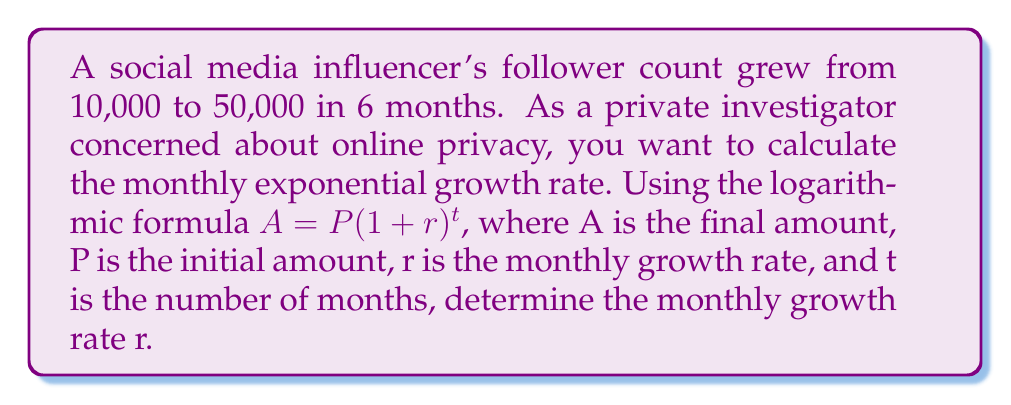Help me with this question. 1. Identify the given values:
   $A = 50,000$ (final follower count)
   $P = 10,000$ (initial follower count)
   $t = 6$ (months)

2. Substitute these values into the formula:
   $50,000 = 10,000(1+r)^6$

3. Divide both sides by 10,000:
   $5 = (1+r)^6$

4. Take the natural logarithm of both sides:
   $\ln(5) = \ln((1+r)^6)$

5. Use the logarithm property $\ln(x^n) = n\ln(x)$:
   $\ln(5) = 6\ln(1+r)$

6. Divide both sides by 6:
   $\frac{\ln(5)}{6} = \ln(1+r)$

7. Take $e$ to the power of both sides:
   $e^{\frac{\ln(5)}{6}} = e^{\ln(1+r)} = 1+r$

8. Subtract 1 from both sides:
   $e^{\frac{\ln(5)}{6}} - 1 = r$

9. Calculate the result:
   $r \approx 0.2934$ or 29.34%
Answer: 29.34% 